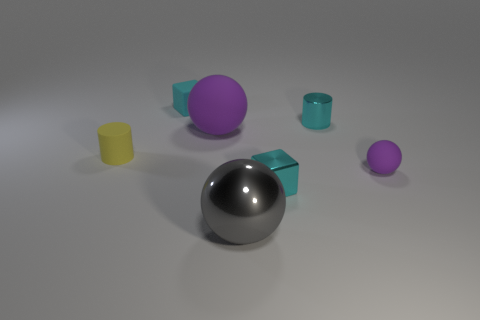Subtract all green cylinders. How many purple balls are left? 2 Subtract all rubber balls. How many balls are left? 1 Add 2 small blocks. How many objects exist? 9 Subtract all cylinders. How many objects are left? 5 Add 7 brown shiny cubes. How many brown shiny cubes exist? 7 Subtract 0 purple cubes. How many objects are left? 7 Subtract all small cubes. Subtract all yellow matte things. How many objects are left? 4 Add 5 rubber cubes. How many rubber cubes are left? 6 